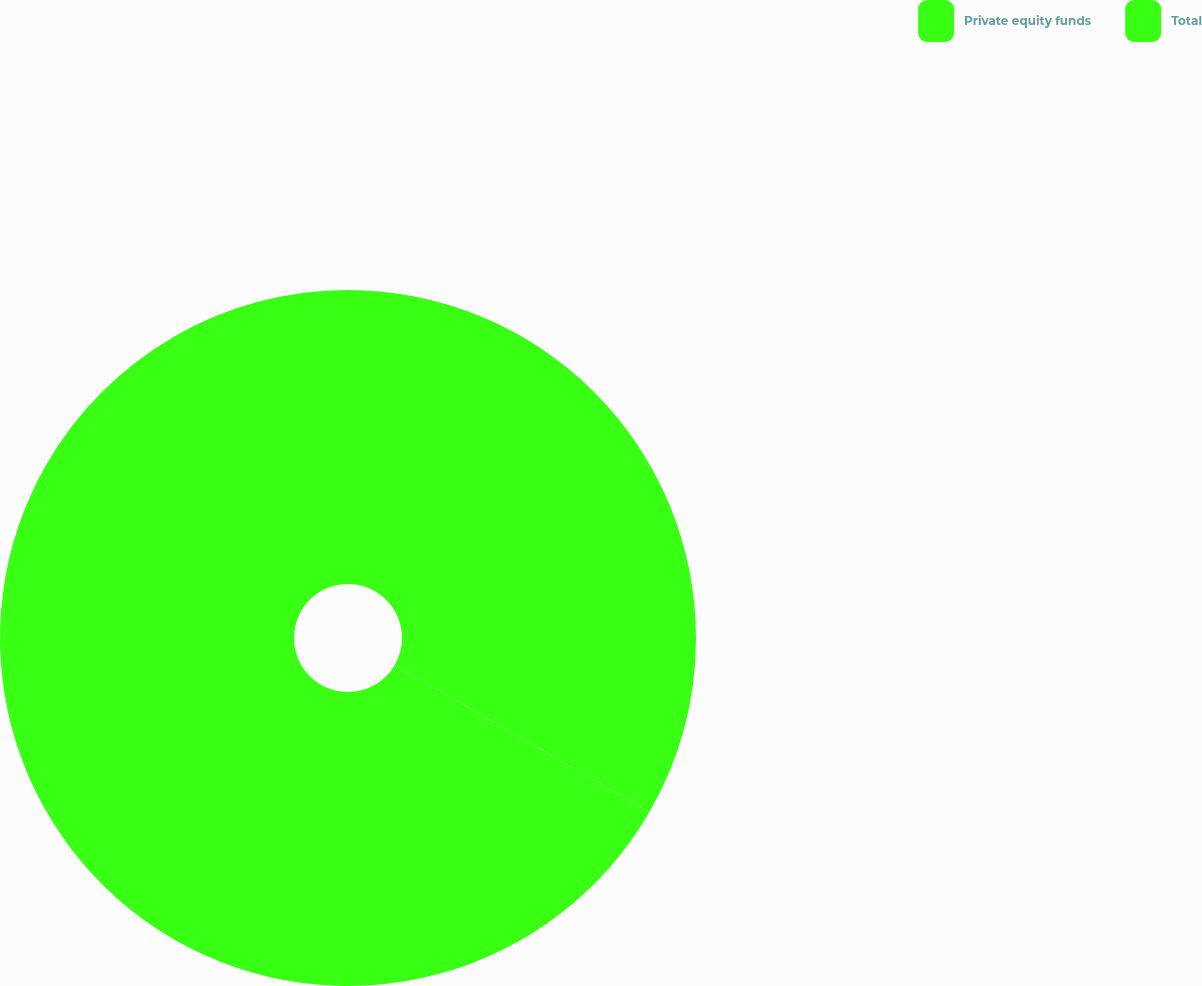<chart> <loc_0><loc_0><loc_500><loc_500><pie_chart><fcel>Private equity funds<fcel>Total<nl><fcel>33.33%<fcel>66.67%<nl></chart> 